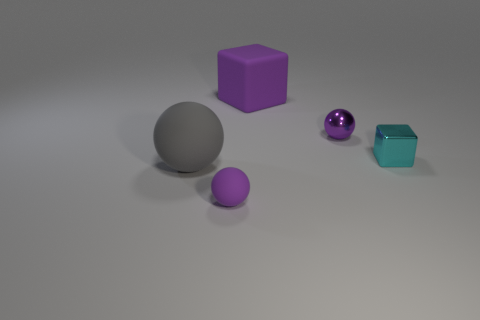There is another object that is made of the same material as the tiny cyan thing; what is its size?
Make the answer very short. Small. What shape is the object that is on the right side of the purple ball that is to the right of the large purple matte cube?
Your answer should be compact. Cube. How big is the thing that is both in front of the tiny purple shiny ball and on the right side of the matte cube?
Your response must be concise. Small. Are there any tiny metal objects of the same shape as the large gray thing?
Provide a succinct answer. Yes. There is a purple object right of the block to the left of the small purple sphere behind the small cyan metallic thing; what is it made of?
Your answer should be compact. Metal. Are there any purple matte cylinders of the same size as the shiny ball?
Provide a short and direct response. No. What is the color of the matte object on the left side of the purple sphere that is left of the large block?
Keep it short and to the point. Gray. How many blocks are there?
Offer a very short reply. 2. Is the matte block the same color as the tiny metal sphere?
Your answer should be very brief. Yes. Are there fewer cyan metallic things that are in front of the small purple matte sphere than small metal spheres that are behind the gray rubber object?
Keep it short and to the point. Yes. 